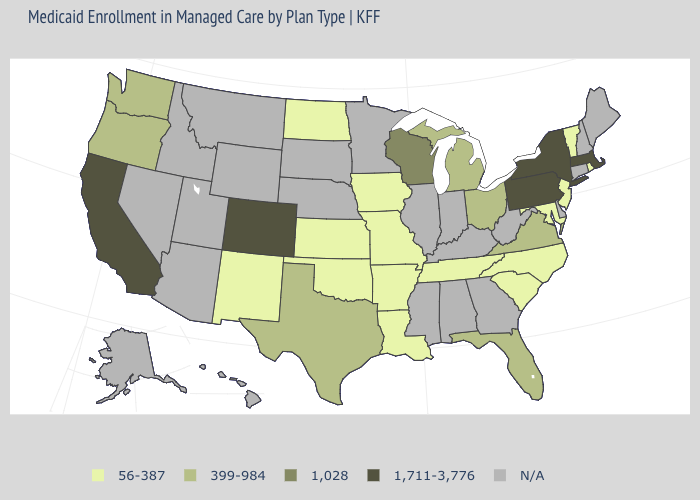Does Massachusetts have the highest value in the USA?
Write a very short answer. Yes. What is the highest value in the USA?
Answer briefly. 1,711-3,776. What is the value of Idaho?
Write a very short answer. N/A. Name the states that have a value in the range 56-387?
Concise answer only. Arkansas, Iowa, Kansas, Louisiana, Maryland, Missouri, New Jersey, New Mexico, North Carolina, North Dakota, Oklahoma, Rhode Island, South Carolina, Tennessee, Vermont. Name the states that have a value in the range 56-387?
Answer briefly. Arkansas, Iowa, Kansas, Louisiana, Maryland, Missouri, New Jersey, New Mexico, North Carolina, North Dakota, Oklahoma, Rhode Island, South Carolina, Tennessee, Vermont. Which states hav the highest value in the MidWest?
Quick response, please. Wisconsin. What is the value of Ohio?
Keep it brief. 399-984. What is the lowest value in the USA?
Give a very brief answer. 56-387. What is the value of South Carolina?
Concise answer only. 56-387. What is the value of Arkansas?
Be succinct. 56-387. Does the map have missing data?
Concise answer only. Yes. Name the states that have a value in the range 56-387?
Give a very brief answer. Arkansas, Iowa, Kansas, Louisiana, Maryland, Missouri, New Jersey, New Mexico, North Carolina, North Dakota, Oklahoma, Rhode Island, South Carolina, Tennessee, Vermont. Is the legend a continuous bar?
Concise answer only. No. Name the states that have a value in the range N/A?
Keep it brief. Alabama, Alaska, Arizona, Connecticut, Delaware, Georgia, Hawaii, Idaho, Illinois, Indiana, Kentucky, Maine, Minnesota, Mississippi, Montana, Nebraska, Nevada, New Hampshire, South Dakota, Utah, West Virginia, Wyoming. 